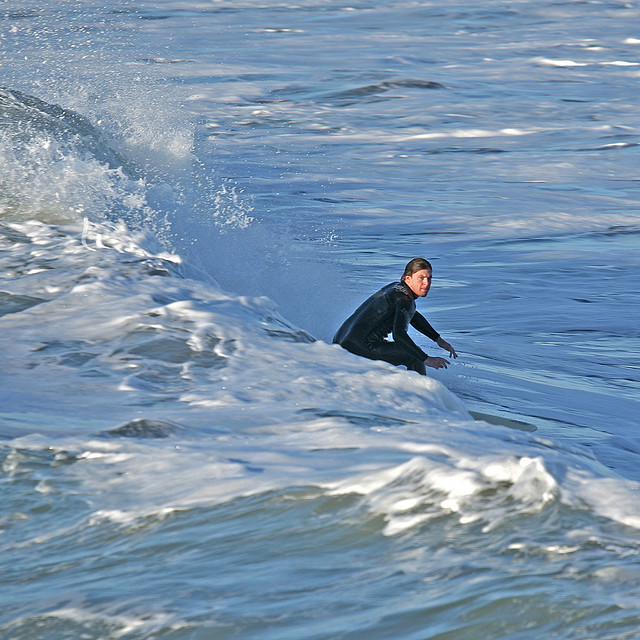<image>Was this picture taken in Miami, Florida? It's unclear if the picture was taken in Miami, Florida. Was this picture taken in Miami, Florida? I don't know if this picture was taken in Miami, Florida. It can be both yes and no. 